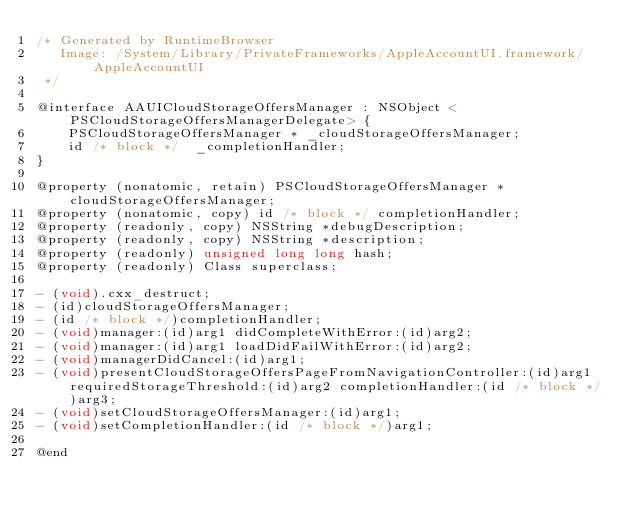<code> <loc_0><loc_0><loc_500><loc_500><_C_>/* Generated by RuntimeBrowser
   Image: /System/Library/PrivateFrameworks/AppleAccountUI.framework/AppleAccountUI
 */

@interface AAUICloudStorageOffersManager : NSObject <PSCloudStorageOffersManagerDelegate> {
    PSCloudStorageOffersManager * _cloudStorageOffersManager;
    id /* block */  _completionHandler;
}

@property (nonatomic, retain) PSCloudStorageOffersManager *cloudStorageOffersManager;
@property (nonatomic, copy) id /* block */ completionHandler;
@property (readonly, copy) NSString *debugDescription;
@property (readonly, copy) NSString *description;
@property (readonly) unsigned long long hash;
@property (readonly) Class superclass;

- (void).cxx_destruct;
- (id)cloudStorageOffersManager;
- (id /* block */)completionHandler;
- (void)manager:(id)arg1 didCompleteWithError:(id)arg2;
- (void)manager:(id)arg1 loadDidFailWithError:(id)arg2;
- (void)managerDidCancel:(id)arg1;
- (void)presentCloudStorageOffersPageFromNavigationController:(id)arg1 requiredStorageThreshold:(id)arg2 completionHandler:(id /* block */)arg3;
- (void)setCloudStorageOffersManager:(id)arg1;
- (void)setCompletionHandler:(id /* block */)arg1;

@end
</code> 